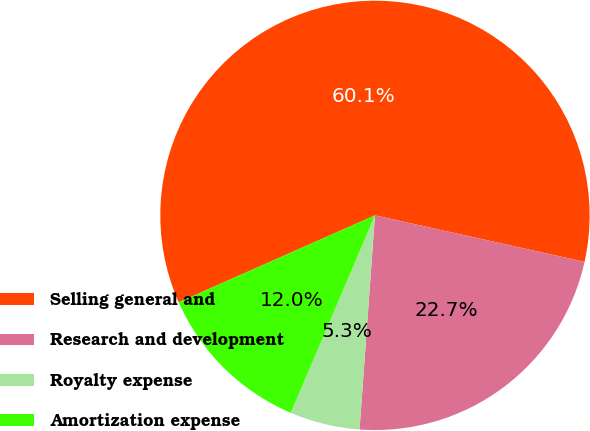Convert chart to OTSL. <chart><loc_0><loc_0><loc_500><loc_500><pie_chart><fcel>Selling general and<fcel>Research and development<fcel>Royalty expense<fcel>Amortization expense<nl><fcel>60.11%<fcel>22.67%<fcel>5.27%<fcel>11.95%<nl></chart> 